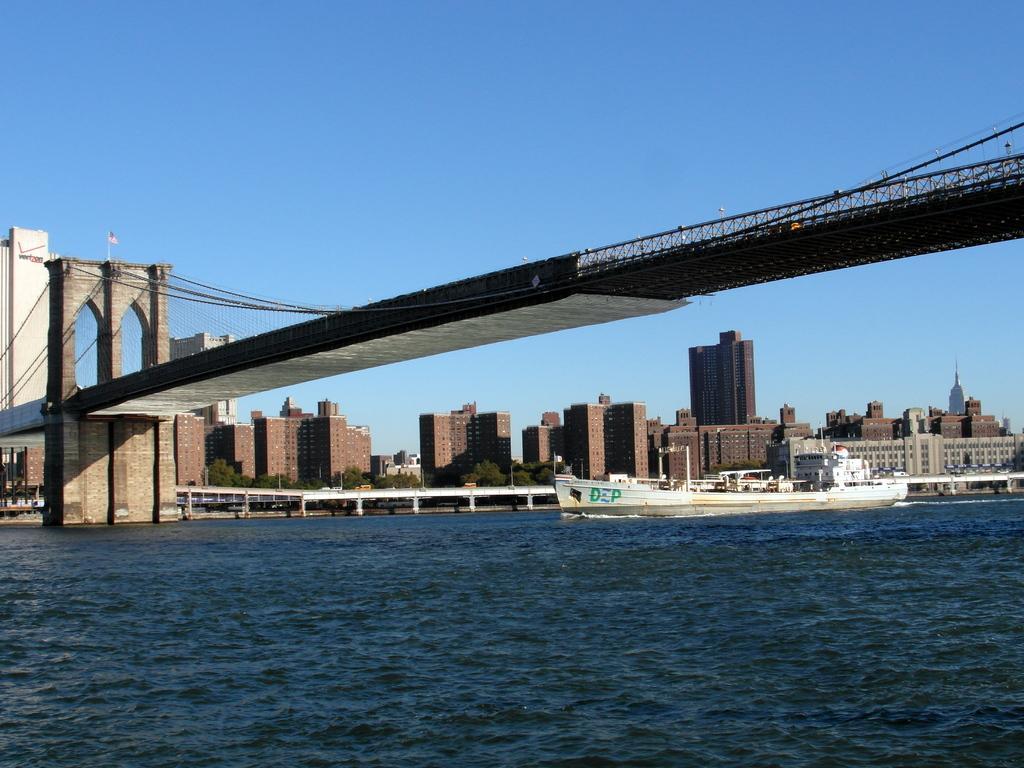Can you describe this image briefly? In this picture I can see few buildings and a ship in the water and I can see a bridge and a blue sky. 